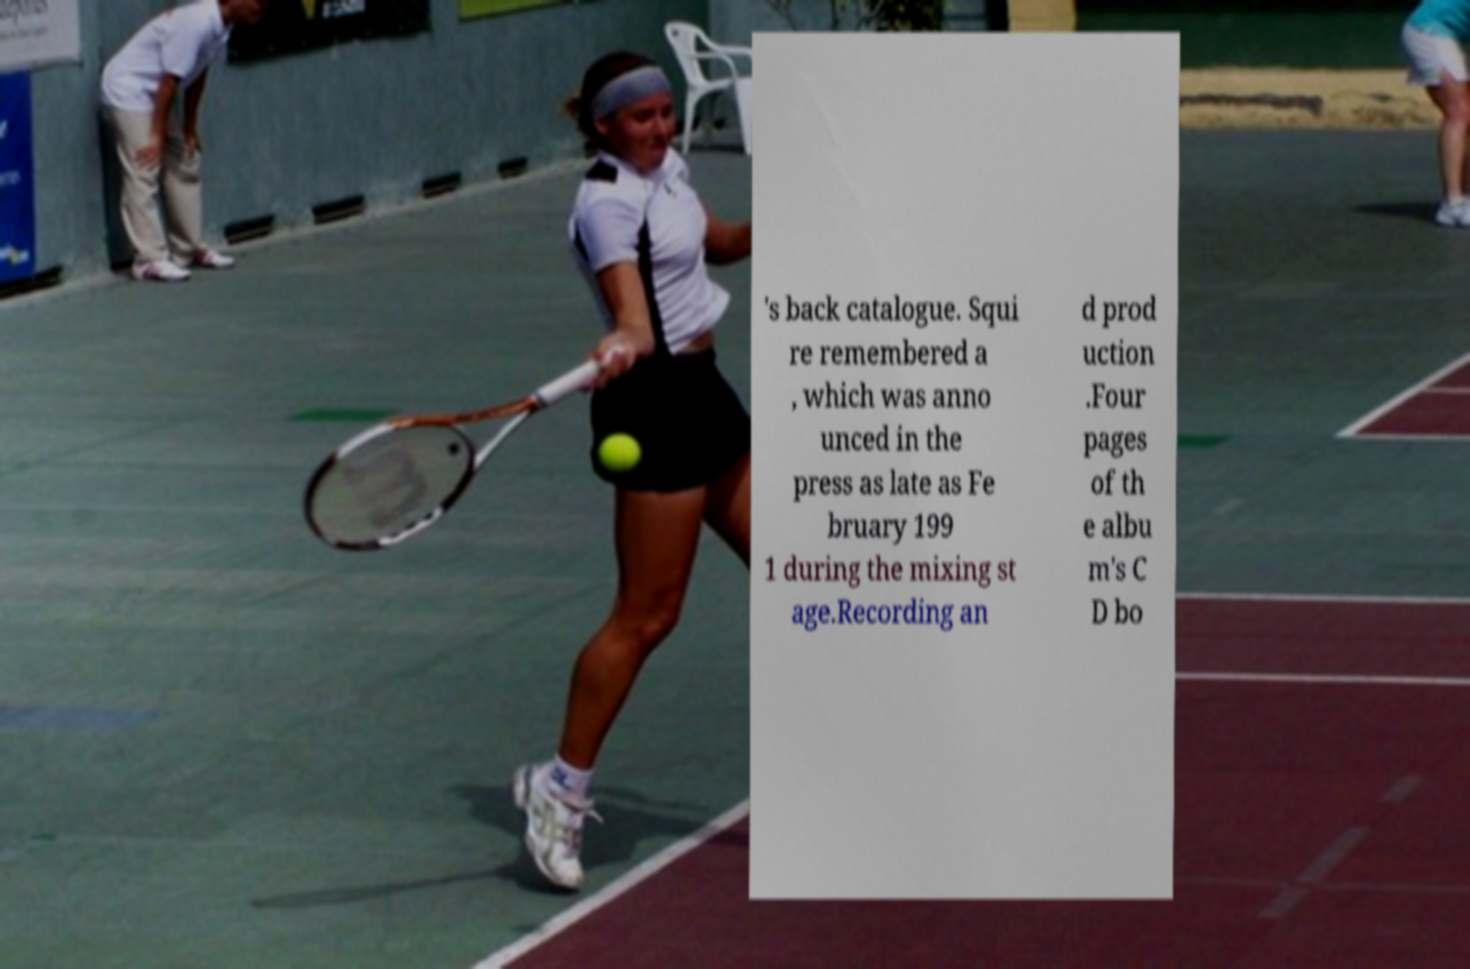Could you assist in decoding the text presented in this image and type it out clearly? 's back catalogue. Squi re remembered a , which was anno unced in the press as late as Fe bruary 199 1 during the mixing st age.Recording an d prod uction .Four pages of th e albu m's C D bo 